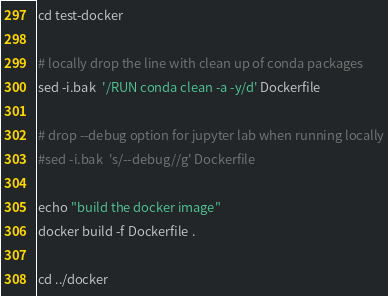<code> <loc_0><loc_0><loc_500><loc_500><_Bash_>
cd test-docker

# locally drop the line with clean up of conda packages
sed -i.bak  '/RUN conda clean -a -y/d' Dockerfile

# drop --debug option for jupyter lab when running locally
#sed -i.bak  's/--debug//g' Dockerfile

echo "build the docker image"
docker build -f Dockerfile .

cd ../docker
</code> 